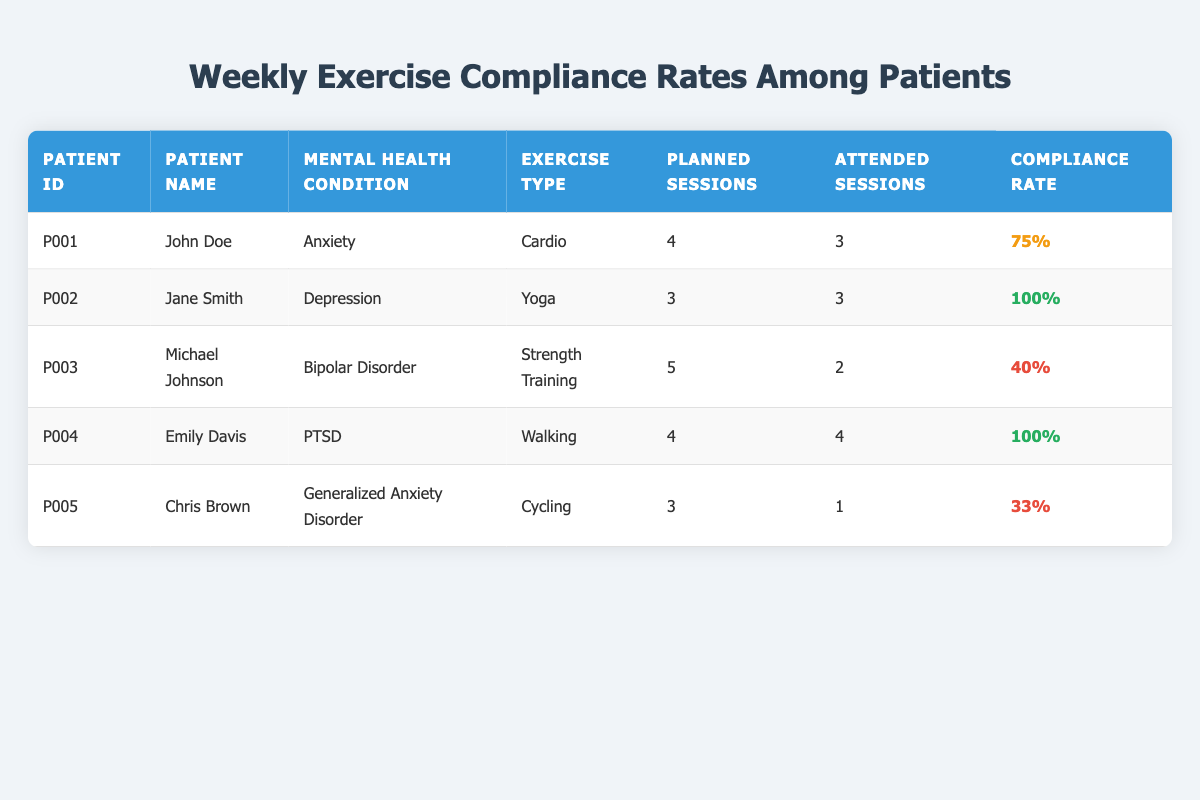What is the compliance rate for Jane Smith? According to the table, Jane Smith has a compliance rate of 100%. This is indicated in the compliance rate column next to her name.
Answer: 100% How many sessions did Chris Brown attend? The table shows that Chris Brown attended 1 session out of the 3 planned sessions. This information can be found in the attended sessions column next to his name.
Answer: 1 Who has the lowest compliance rate? Michael Johnson has the lowest compliance rate at 40%. By checking the compliance rates for all patients in the table, it is clear that no one else has a rate lower than his.
Answer: Michael Johnson What is the average compliance rate of all patients? To calculate the average compliance rate, we add the compliance rates of all patients (75 + 100 + 40 + 100 + 33 = 348) and then divide by the number of patients (5). Thus, the average is 348/5 = 69.6.
Answer: 69.6 Is the patient with the highest compliance rate suffering from a mood disorder? No, the patients with the highest compliance rates (Jane Smith and Emily Davis) are diagnosed with depression and PTSD, respectively. Neither of these is classified as a mood disorder like bipolar disorder.
Answer: No How many patients planned more than 3 sessions? By reviewing the planned sessions for each patient, we see that Michael Johnson planned 5 sessions, while John Doe and Emily Davis each planned 4 sessions. Therefore, a total of 3 patients planned more than 3 sessions.
Answer: 3 Which exercise type had the highest compliance rate? The exercise types with the highest compliance rates are Yoga and Walking, both at 100%. This can be determined by comparing the compliance rates corresponding to each exercise type in the table.
Answer: Yoga and Walking What is the difference in compliance rates between the patients with anxiety and those with PTSD? For patients with anxiety (John Doe and Chris Brown), the compliance rates are 75% and 33%, respectively, averaging 54%. For the patient with PTSD (Emily Davis), the rate is 100%. The difference between these averages is 100 - 54 = 46.
Answer: 46 How many attended sessions did the patient with Bipolar Disorder have? Michael Johnson, who has Bipolar Disorder, attended 2 sessions as per the attended sessions column in the table.
Answer: 2 